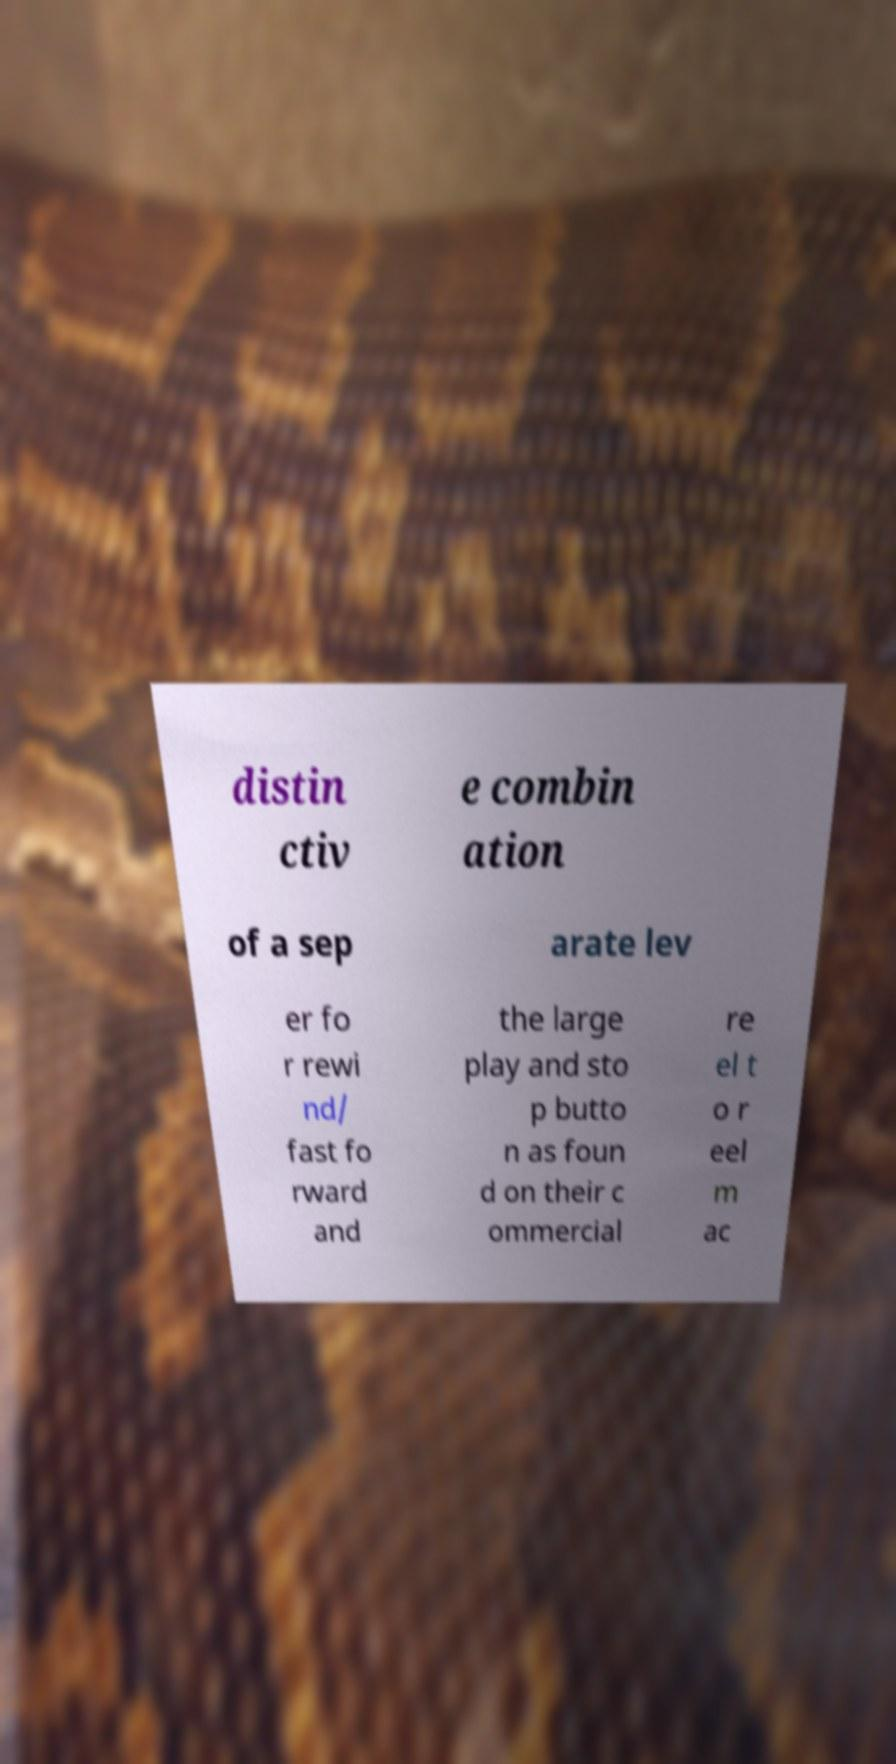For documentation purposes, I need the text within this image transcribed. Could you provide that? distin ctiv e combin ation of a sep arate lev er fo r rewi nd/ fast fo rward and the large play and sto p butto n as foun d on their c ommercial re el t o r eel m ac 